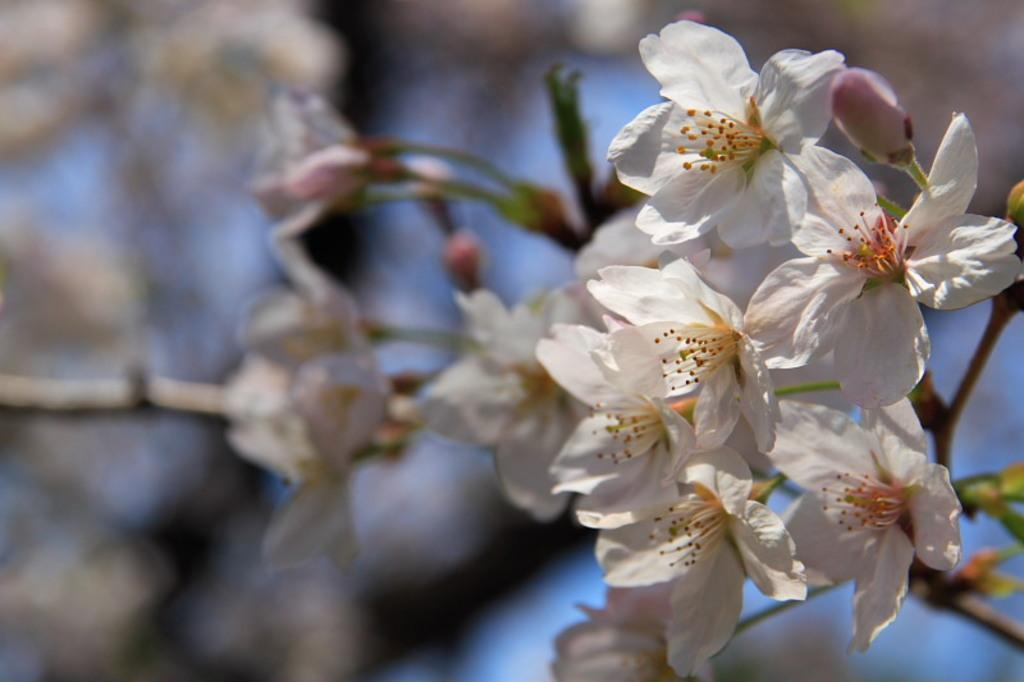What is the visual effect on the background of the image? The background portion of the picture is blurred. What type of flowers can be seen in the image? There are white flowers in the image. What else can be seen connected to the flowers? There are stems in the image. Are there any unopened flowers visible in the image? Yes, there are buds in the image. Can you see a baby playing with a squirrel in the field in the image? There is no baby, squirrel, or field present in the image. What type of creature is interacting with the flowers in the image? There is no creature interacting with the flowers in the image; only the flowers, stems, and buds are present. 